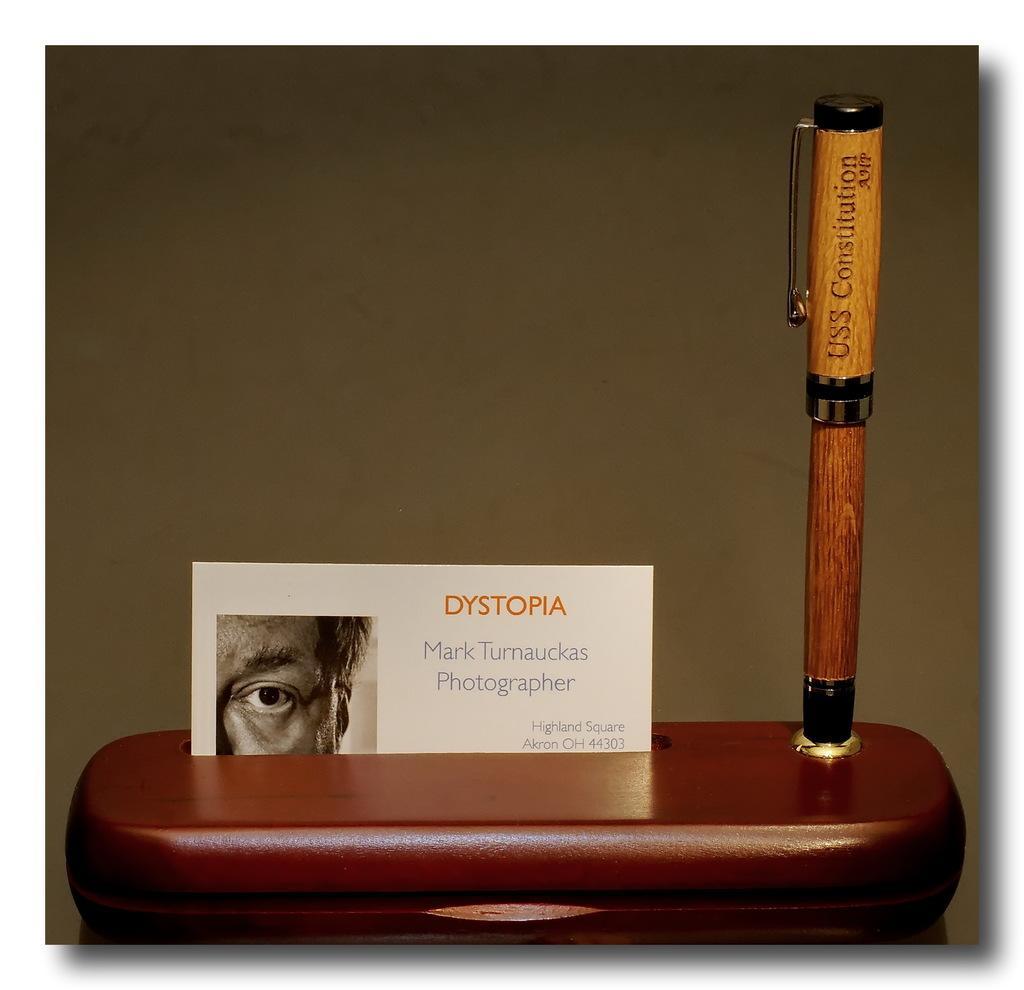Describe this image in one or two sentences. In this image we can see a card with a picture, some text and a pen placed on the surface. In the background, we can see the wall. 